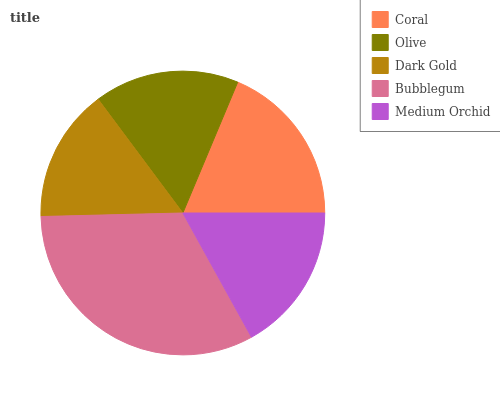Is Dark Gold the minimum?
Answer yes or no. Yes. Is Bubblegum the maximum?
Answer yes or no. Yes. Is Olive the minimum?
Answer yes or no. No. Is Olive the maximum?
Answer yes or no. No. Is Coral greater than Olive?
Answer yes or no. Yes. Is Olive less than Coral?
Answer yes or no. Yes. Is Olive greater than Coral?
Answer yes or no. No. Is Coral less than Olive?
Answer yes or no. No. Is Medium Orchid the high median?
Answer yes or no. Yes. Is Medium Orchid the low median?
Answer yes or no. Yes. Is Dark Gold the high median?
Answer yes or no. No. Is Dark Gold the low median?
Answer yes or no. No. 